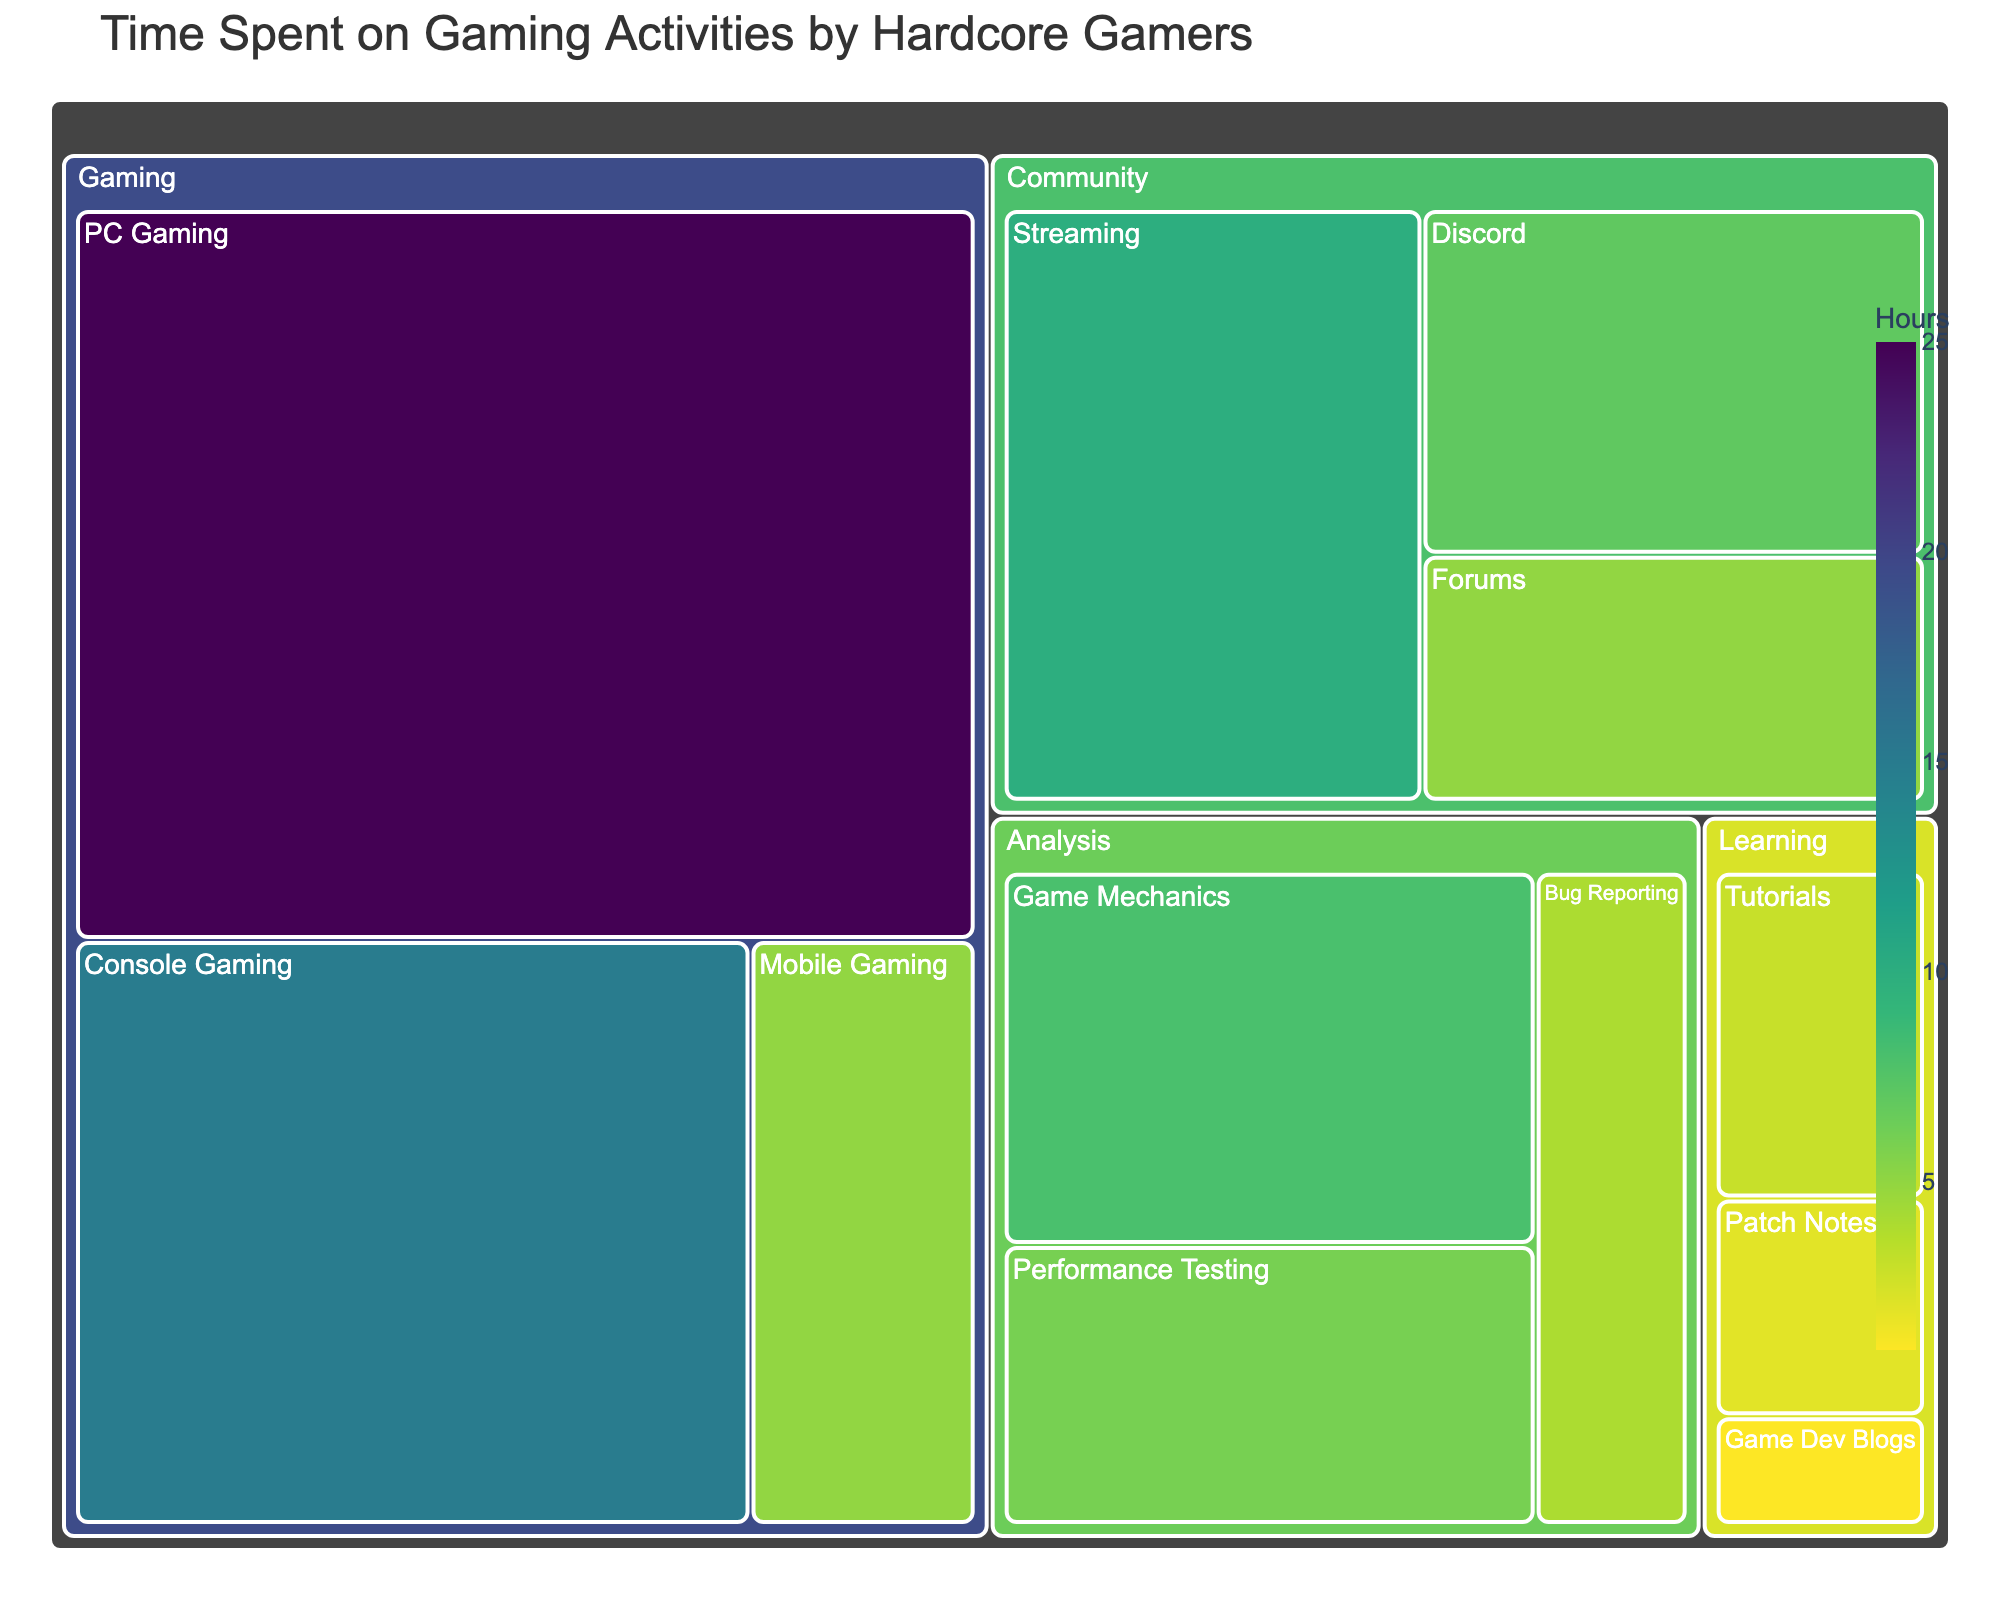What is the title of the Treemap? The title is usually prominently displayed at the top of the treemap. It summarizes the main topic of the visualization.
Answer: Time Spent on Gaming Activities by Hardcore Gamers Which category has the highest total hours? The largest block within the treemap usually represents the category with the highest total hours. Here, the 'Gaming' category is the largest.
Answer: Gaming How many subcategories are under the 'Community' category? By observing the 'Community' block, you can count the divisions within it for the subcategories. There are three blocks under 'Community'.
Answer: 3 Which subcategory has the least hours under the 'Learning' category? Among the subcategories under 'Learning', the smallest block represents the one with the least hours. 'Game Dev Blogs' is the smallest block in this category.
Answer: Game Dev Blogs What are the total hours spent on 'Analysis' activities? Sum the hours of all subcategories under the 'Analysis' category: 8 (Game Mechanics) + 6 (Performance Testing) + 4 (Bug Reporting). The total is 18.
Answer: 18 How does the total time spent on 'Streaming' compare to 'Discord'? Compare the sizes of the blocks and the numbers shown for 'Streaming' and 'Discord'. 'Streaming' has 10 hours, while 'Discord' has 7 hours.
Answer: Streaming has more time spent than Discord What is the average time spent on 'Gaming' activities? Add the hours of all subcategories under 'Gaming': 25 (PC Gaming) + 15 (Console Gaming) + 5 (Mobile Gaming). Sum is 45. Average is 45 divided by 3 subcategories.
Answer: 15 Which subcategory under 'Gaming' has the highest hours? Within the 'Gaming' category, the subcategory with the largest block and the highest number of hours is 'PC Gaming'.
Answer: PC Gaming What is the color used for the highest number of hours? The visual color representation for the highest number of hours should be the darkest or most intense shade on the color scale.
Answer: Darkest shade on the color scale What is the total number of hours spent on 'Mobile Gaming' and 'Game Mechanics'? Add the hours of 'Mobile Gaming' and 'Game Mechanics': 5 (Mobile Gaming) + 8 (Game Mechanics). The total is 13.
Answer: 13 